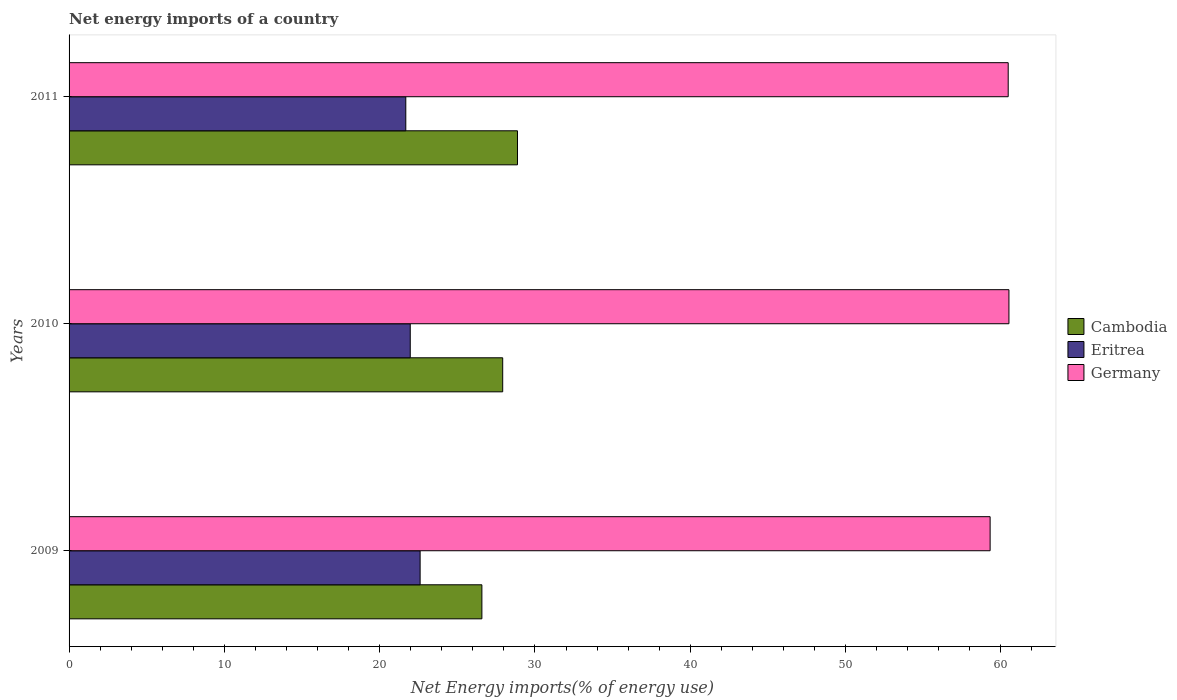How many different coloured bars are there?
Offer a very short reply. 3. Are the number of bars on each tick of the Y-axis equal?
Keep it short and to the point. Yes. How many bars are there on the 2nd tick from the top?
Make the answer very short. 3. How many bars are there on the 2nd tick from the bottom?
Give a very brief answer. 3. What is the label of the 3rd group of bars from the top?
Give a very brief answer. 2009. In how many cases, is the number of bars for a given year not equal to the number of legend labels?
Offer a terse response. 0. What is the net energy imports in Eritrea in 2009?
Make the answer very short. 22.61. Across all years, what is the maximum net energy imports in Cambodia?
Offer a terse response. 28.88. Across all years, what is the minimum net energy imports in Cambodia?
Ensure brevity in your answer.  26.58. In which year was the net energy imports in Eritrea maximum?
Keep it short and to the point. 2009. In which year was the net energy imports in Germany minimum?
Your response must be concise. 2009. What is the total net energy imports in Germany in the graph?
Your response must be concise. 180.3. What is the difference between the net energy imports in Germany in 2009 and that in 2011?
Make the answer very short. -1.16. What is the difference between the net energy imports in Germany in 2010 and the net energy imports in Cambodia in 2009?
Offer a terse response. 33.94. What is the average net energy imports in Cambodia per year?
Your response must be concise. 27.79. In the year 2010, what is the difference between the net energy imports in Germany and net energy imports in Cambodia?
Provide a succinct answer. 32.6. In how many years, is the net energy imports in Germany greater than 44 %?
Provide a succinct answer. 3. What is the ratio of the net energy imports in Germany in 2010 to that in 2011?
Your response must be concise. 1. Is the difference between the net energy imports in Germany in 2009 and 2010 greater than the difference between the net energy imports in Cambodia in 2009 and 2010?
Provide a succinct answer. Yes. What is the difference between the highest and the second highest net energy imports in Eritrea?
Provide a succinct answer. 0.64. What is the difference between the highest and the lowest net energy imports in Germany?
Provide a short and direct response. 1.21. What does the 1st bar from the bottom in 2011 represents?
Your answer should be very brief. Cambodia. Is it the case that in every year, the sum of the net energy imports in Eritrea and net energy imports in Cambodia is greater than the net energy imports in Germany?
Offer a terse response. No. What is the difference between two consecutive major ticks on the X-axis?
Ensure brevity in your answer.  10. Are the values on the major ticks of X-axis written in scientific E-notation?
Your answer should be very brief. No. Does the graph contain grids?
Ensure brevity in your answer.  No. Where does the legend appear in the graph?
Your response must be concise. Center right. How many legend labels are there?
Your answer should be compact. 3. How are the legend labels stacked?
Offer a very short reply. Vertical. What is the title of the graph?
Provide a short and direct response. Net energy imports of a country. What is the label or title of the X-axis?
Your response must be concise. Net Energy imports(% of energy use). What is the Net Energy imports(% of energy use) in Cambodia in 2009?
Give a very brief answer. 26.58. What is the Net Energy imports(% of energy use) in Eritrea in 2009?
Offer a terse response. 22.61. What is the Net Energy imports(% of energy use) of Germany in 2009?
Offer a very short reply. 59.31. What is the Net Energy imports(% of energy use) of Cambodia in 2010?
Your answer should be compact. 27.92. What is the Net Energy imports(% of energy use) in Eritrea in 2010?
Keep it short and to the point. 21.97. What is the Net Energy imports(% of energy use) in Germany in 2010?
Offer a terse response. 60.52. What is the Net Energy imports(% of energy use) in Cambodia in 2011?
Provide a succinct answer. 28.88. What is the Net Energy imports(% of energy use) in Eritrea in 2011?
Your answer should be compact. 21.68. What is the Net Energy imports(% of energy use) of Germany in 2011?
Your response must be concise. 60.47. Across all years, what is the maximum Net Energy imports(% of energy use) in Cambodia?
Offer a terse response. 28.88. Across all years, what is the maximum Net Energy imports(% of energy use) of Eritrea?
Make the answer very short. 22.61. Across all years, what is the maximum Net Energy imports(% of energy use) in Germany?
Give a very brief answer. 60.52. Across all years, what is the minimum Net Energy imports(% of energy use) of Cambodia?
Make the answer very short. 26.58. Across all years, what is the minimum Net Energy imports(% of energy use) of Eritrea?
Offer a terse response. 21.68. Across all years, what is the minimum Net Energy imports(% of energy use) in Germany?
Ensure brevity in your answer.  59.31. What is the total Net Energy imports(% of energy use) of Cambodia in the graph?
Ensure brevity in your answer.  83.38. What is the total Net Energy imports(% of energy use) in Eritrea in the graph?
Your answer should be compact. 66.26. What is the total Net Energy imports(% of energy use) in Germany in the graph?
Ensure brevity in your answer.  180.31. What is the difference between the Net Energy imports(% of energy use) of Cambodia in 2009 and that in 2010?
Your answer should be compact. -1.34. What is the difference between the Net Energy imports(% of energy use) in Eritrea in 2009 and that in 2010?
Provide a short and direct response. 0.64. What is the difference between the Net Energy imports(% of energy use) of Germany in 2009 and that in 2010?
Your answer should be compact. -1.21. What is the difference between the Net Energy imports(% of energy use) in Cambodia in 2009 and that in 2011?
Ensure brevity in your answer.  -2.29. What is the difference between the Net Energy imports(% of energy use) in Eritrea in 2009 and that in 2011?
Your answer should be very brief. 0.92. What is the difference between the Net Energy imports(% of energy use) in Germany in 2009 and that in 2011?
Make the answer very short. -1.16. What is the difference between the Net Energy imports(% of energy use) of Cambodia in 2010 and that in 2011?
Offer a terse response. -0.95. What is the difference between the Net Energy imports(% of energy use) of Eritrea in 2010 and that in 2011?
Your response must be concise. 0.29. What is the difference between the Net Energy imports(% of energy use) in Germany in 2010 and that in 2011?
Offer a terse response. 0.05. What is the difference between the Net Energy imports(% of energy use) of Cambodia in 2009 and the Net Energy imports(% of energy use) of Eritrea in 2010?
Provide a succinct answer. 4.61. What is the difference between the Net Energy imports(% of energy use) of Cambodia in 2009 and the Net Energy imports(% of energy use) of Germany in 2010?
Offer a very short reply. -33.94. What is the difference between the Net Energy imports(% of energy use) of Eritrea in 2009 and the Net Energy imports(% of energy use) of Germany in 2010?
Give a very brief answer. -37.92. What is the difference between the Net Energy imports(% of energy use) in Cambodia in 2009 and the Net Energy imports(% of energy use) in Eritrea in 2011?
Your answer should be very brief. 4.9. What is the difference between the Net Energy imports(% of energy use) in Cambodia in 2009 and the Net Energy imports(% of energy use) in Germany in 2011?
Offer a very short reply. -33.89. What is the difference between the Net Energy imports(% of energy use) in Eritrea in 2009 and the Net Energy imports(% of energy use) in Germany in 2011?
Offer a terse response. -37.87. What is the difference between the Net Energy imports(% of energy use) in Cambodia in 2010 and the Net Energy imports(% of energy use) in Eritrea in 2011?
Offer a very short reply. 6.24. What is the difference between the Net Energy imports(% of energy use) of Cambodia in 2010 and the Net Energy imports(% of energy use) of Germany in 2011?
Offer a very short reply. -32.55. What is the difference between the Net Energy imports(% of energy use) in Eritrea in 2010 and the Net Energy imports(% of energy use) in Germany in 2011?
Offer a terse response. -38.5. What is the average Net Energy imports(% of energy use) of Cambodia per year?
Provide a succinct answer. 27.79. What is the average Net Energy imports(% of energy use) in Eritrea per year?
Ensure brevity in your answer.  22.09. What is the average Net Energy imports(% of energy use) of Germany per year?
Make the answer very short. 60.1. In the year 2009, what is the difference between the Net Energy imports(% of energy use) in Cambodia and Net Energy imports(% of energy use) in Eritrea?
Offer a very short reply. 3.98. In the year 2009, what is the difference between the Net Energy imports(% of energy use) in Cambodia and Net Energy imports(% of energy use) in Germany?
Your answer should be very brief. -32.73. In the year 2009, what is the difference between the Net Energy imports(% of energy use) in Eritrea and Net Energy imports(% of energy use) in Germany?
Provide a succinct answer. -36.7. In the year 2010, what is the difference between the Net Energy imports(% of energy use) of Cambodia and Net Energy imports(% of energy use) of Eritrea?
Keep it short and to the point. 5.95. In the year 2010, what is the difference between the Net Energy imports(% of energy use) in Cambodia and Net Energy imports(% of energy use) in Germany?
Make the answer very short. -32.6. In the year 2010, what is the difference between the Net Energy imports(% of energy use) in Eritrea and Net Energy imports(% of energy use) in Germany?
Provide a succinct answer. -38.55. In the year 2011, what is the difference between the Net Energy imports(% of energy use) of Cambodia and Net Energy imports(% of energy use) of Eritrea?
Offer a very short reply. 7.19. In the year 2011, what is the difference between the Net Energy imports(% of energy use) of Cambodia and Net Energy imports(% of energy use) of Germany?
Offer a terse response. -31.6. In the year 2011, what is the difference between the Net Energy imports(% of energy use) in Eritrea and Net Energy imports(% of energy use) in Germany?
Your response must be concise. -38.79. What is the ratio of the Net Energy imports(% of energy use) of Eritrea in 2009 to that in 2010?
Your response must be concise. 1.03. What is the ratio of the Net Energy imports(% of energy use) in Cambodia in 2009 to that in 2011?
Your answer should be compact. 0.92. What is the ratio of the Net Energy imports(% of energy use) of Eritrea in 2009 to that in 2011?
Your answer should be compact. 1.04. What is the ratio of the Net Energy imports(% of energy use) in Germany in 2009 to that in 2011?
Keep it short and to the point. 0.98. What is the ratio of the Net Energy imports(% of energy use) in Eritrea in 2010 to that in 2011?
Keep it short and to the point. 1.01. What is the difference between the highest and the second highest Net Energy imports(% of energy use) of Cambodia?
Your answer should be compact. 0.95. What is the difference between the highest and the second highest Net Energy imports(% of energy use) in Eritrea?
Give a very brief answer. 0.64. What is the difference between the highest and the second highest Net Energy imports(% of energy use) of Germany?
Your answer should be compact. 0.05. What is the difference between the highest and the lowest Net Energy imports(% of energy use) of Cambodia?
Provide a short and direct response. 2.29. What is the difference between the highest and the lowest Net Energy imports(% of energy use) of Eritrea?
Your response must be concise. 0.92. What is the difference between the highest and the lowest Net Energy imports(% of energy use) of Germany?
Offer a terse response. 1.21. 